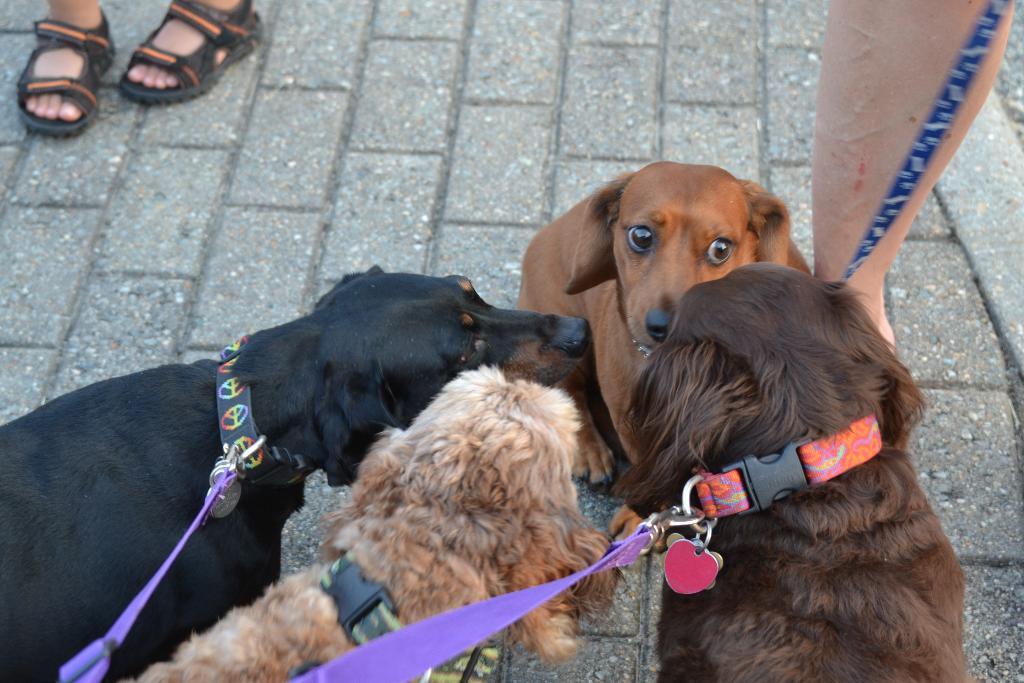Please provide a concise description of this image. In the center of the image there are dogs and we can see legs of people. 